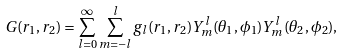Convert formula to latex. <formula><loc_0><loc_0><loc_500><loc_500>G ( r _ { 1 } , r _ { 2 } ) = \sum _ { l = 0 } ^ { \infty } \sum _ { m = - l } ^ { l } g _ { l } ( r _ { 1 } , r _ { 2 } ) Y _ { m } ^ { l } ( \theta _ { 1 } , \phi _ { 1 } ) Y _ { m } ^ { l } ( \theta _ { 2 } , \phi _ { 2 } ) ,</formula> 